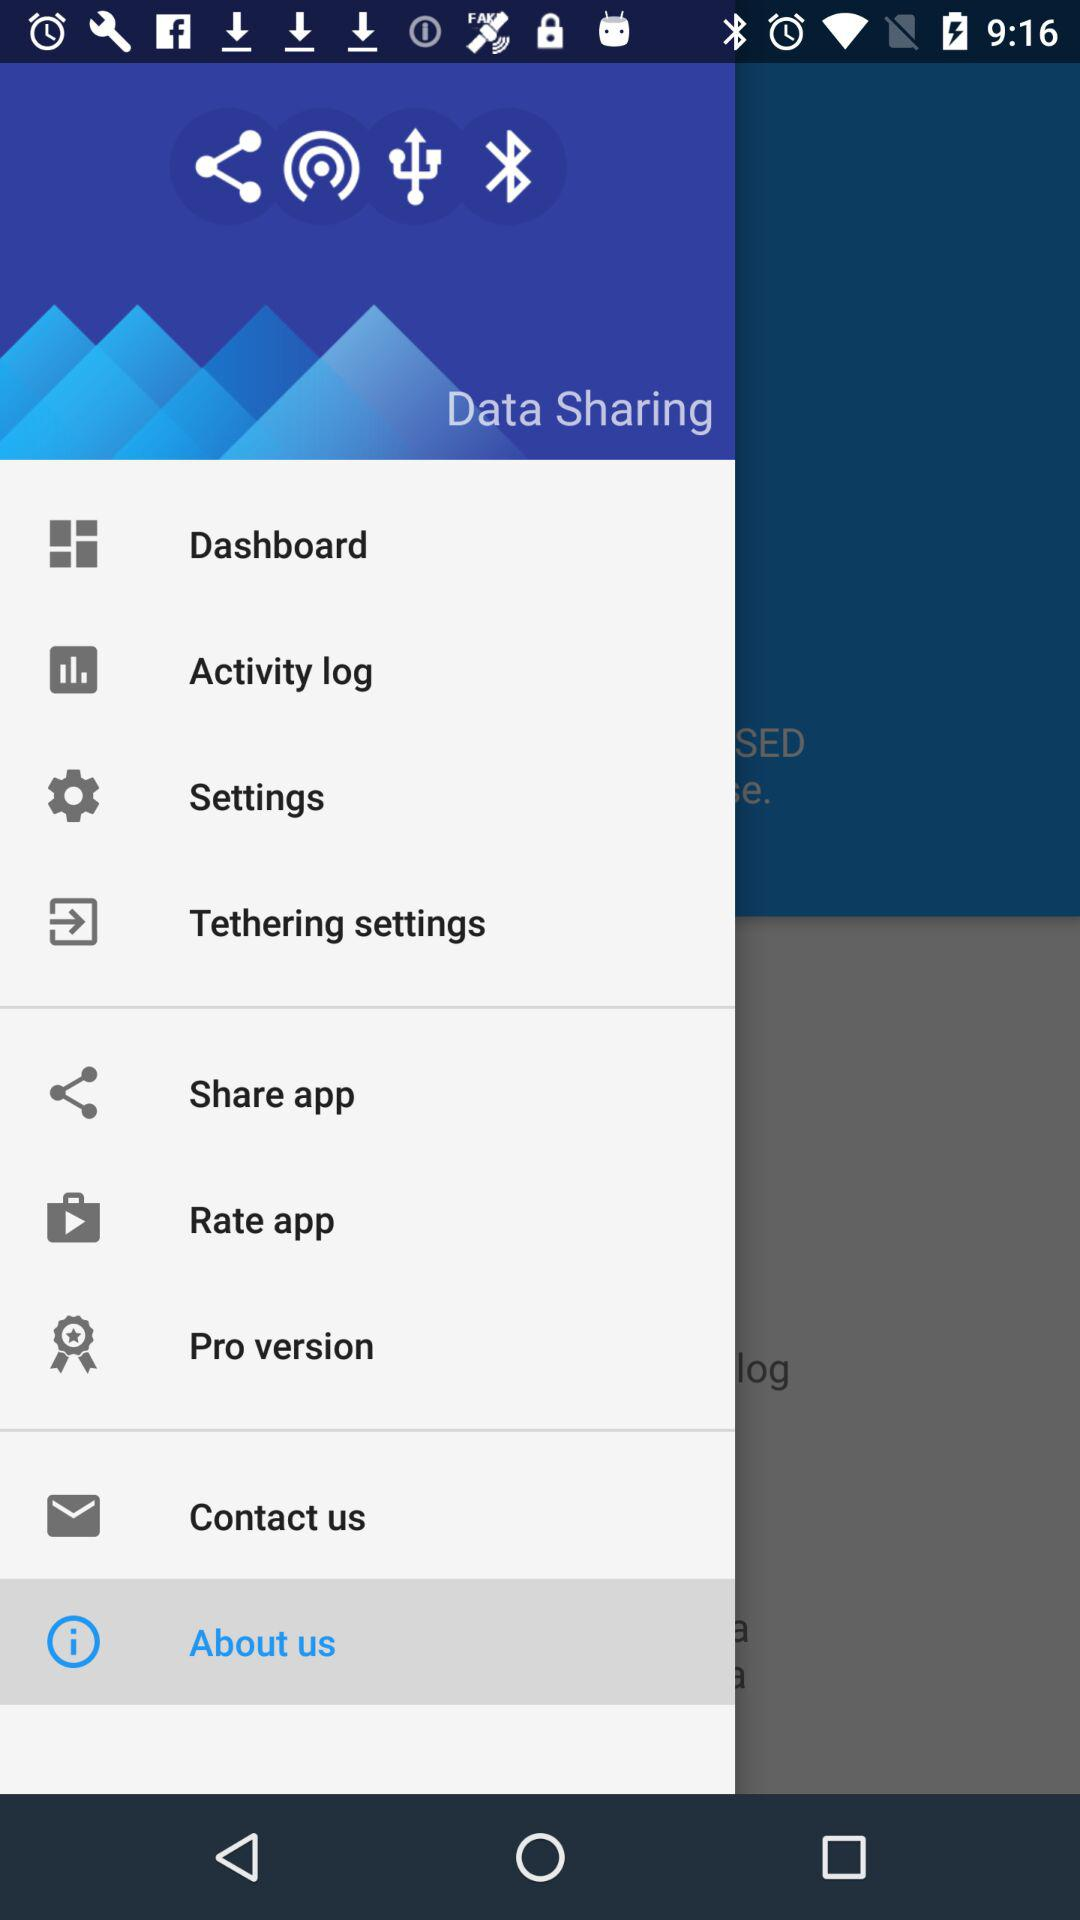Which item is selected? The selected item is "About us". 